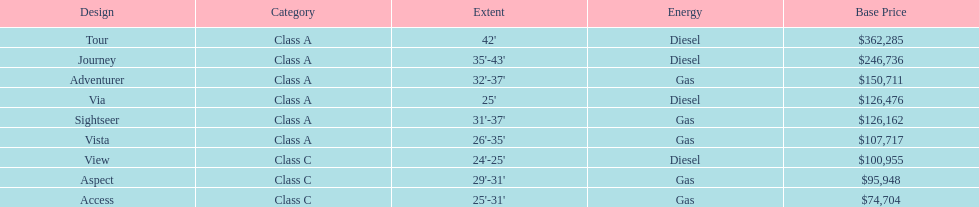Is the vista more than the aspect? Yes. 